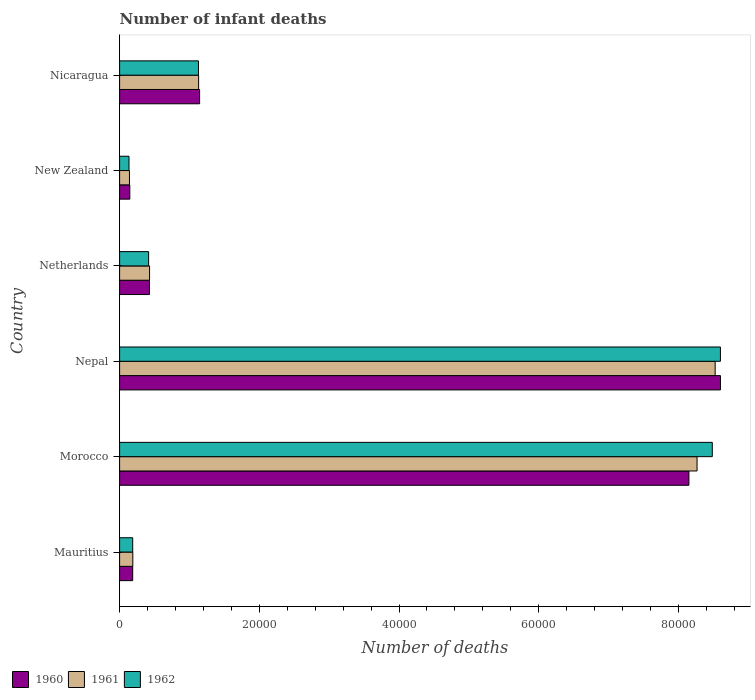Are the number of bars on each tick of the Y-axis equal?
Make the answer very short. Yes. What is the label of the 3rd group of bars from the top?
Make the answer very short. Netherlands. In how many cases, is the number of bars for a given country not equal to the number of legend labels?
Keep it short and to the point. 0. What is the number of infant deaths in 1960 in Netherlands?
Offer a very short reply. 4275. Across all countries, what is the maximum number of infant deaths in 1962?
Offer a terse response. 8.60e+04. Across all countries, what is the minimum number of infant deaths in 1962?
Your response must be concise. 1346. In which country was the number of infant deaths in 1962 maximum?
Keep it short and to the point. Nepal. In which country was the number of infant deaths in 1961 minimum?
Ensure brevity in your answer.  New Zealand. What is the total number of infant deaths in 1961 in the graph?
Provide a short and direct response. 1.87e+05. What is the difference between the number of infant deaths in 1960 in Morocco and that in Netherlands?
Offer a very short reply. 7.72e+04. What is the difference between the number of infant deaths in 1960 in New Zealand and the number of infant deaths in 1962 in Netherlands?
Provide a short and direct response. -2694. What is the average number of infant deaths in 1962 per country?
Offer a very short reply. 3.16e+04. What is the difference between the number of infant deaths in 1960 and number of infant deaths in 1962 in Netherlands?
Your answer should be compact. 120. What is the ratio of the number of infant deaths in 1960 in Mauritius to that in Nepal?
Give a very brief answer. 0.02. Is the difference between the number of infant deaths in 1960 in Netherlands and New Zealand greater than the difference between the number of infant deaths in 1962 in Netherlands and New Zealand?
Provide a succinct answer. Yes. What is the difference between the highest and the second highest number of infant deaths in 1962?
Make the answer very short. 1161. What is the difference between the highest and the lowest number of infant deaths in 1962?
Offer a very short reply. 8.47e+04. In how many countries, is the number of infant deaths in 1961 greater than the average number of infant deaths in 1961 taken over all countries?
Provide a succinct answer. 2. What does the 1st bar from the bottom in Nepal represents?
Provide a short and direct response. 1960. Is it the case that in every country, the sum of the number of infant deaths in 1961 and number of infant deaths in 1962 is greater than the number of infant deaths in 1960?
Make the answer very short. Yes. How many bars are there?
Give a very brief answer. 18. Are the values on the major ticks of X-axis written in scientific E-notation?
Provide a short and direct response. No. Where does the legend appear in the graph?
Offer a very short reply. Bottom left. What is the title of the graph?
Keep it short and to the point. Number of infant deaths. What is the label or title of the X-axis?
Provide a short and direct response. Number of deaths. What is the label or title of the Y-axis?
Offer a terse response. Country. What is the Number of deaths of 1960 in Mauritius?
Offer a very short reply. 1875. What is the Number of deaths of 1961 in Mauritius?
Offer a very short reply. 1890. What is the Number of deaths in 1962 in Mauritius?
Provide a succinct answer. 1876. What is the Number of deaths in 1960 in Morocco?
Your answer should be compact. 8.15e+04. What is the Number of deaths of 1961 in Morocco?
Provide a succinct answer. 8.27e+04. What is the Number of deaths in 1962 in Morocco?
Make the answer very short. 8.48e+04. What is the Number of deaths of 1960 in Nepal?
Provide a short and direct response. 8.60e+04. What is the Number of deaths in 1961 in Nepal?
Provide a succinct answer. 8.53e+04. What is the Number of deaths of 1962 in Nepal?
Provide a succinct answer. 8.60e+04. What is the Number of deaths of 1960 in Netherlands?
Your answer should be compact. 4275. What is the Number of deaths in 1961 in Netherlands?
Your answer should be very brief. 4288. What is the Number of deaths in 1962 in Netherlands?
Give a very brief answer. 4155. What is the Number of deaths in 1960 in New Zealand?
Provide a succinct answer. 1461. What is the Number of deaths in 1961 in New Zealand?
Offer a very short reply. 1412. What is the Number of deaths of 1962 in New Zealand?
Provide a short and direct response. 1346. What is the Number of deaths in 1960 in Nicaragua?
Your response must be concise. 1.15e+04. What is the Number of deaths in 1961 in Nicaragua?
Keep it short and to the point. 1.13e+04. What is the Number of deaths in 1962 in Nicaragua?
Ensure brevity in your answer.  1.13e+04. Across all countries, what is the maximum Number of deaths of 1960?
Keep it short and to the point. 8.60e+04. Across all countries, what is the maximum Number of deaths of 1961?
Your answer should be compact. 8.53e+04. Across all countries, what is the maximum Number of deaths in 1962?
Your response must be concise. 8.60e+04. Across all countries, what is the minimum Number of deaths in 1960?
Provide a short and direct response. 1461. Across all countries, what is the minimum Number of deaths in 1961?
Make the answer very short. 1412. Across all countries, what is the minimum Number of deaths of 1962?
Offer a very short reply. 1346. What is the total Number of deaths of 1960 in the graph?
Keep it short and to the point. 1.87e+05. What is the total Number of deaths in 1961 in the graph?
Offer a very short reply. 1.87e+05. What is the total Number of deaths of 1962 in the graph?
Provide a short and direct response. 1.90e+05. What is the difference between the Number of deaths in 1960 in Mauritius and that in Morocco?
Make the answer very short. -7.96e+04. What is the difference between the Number of deaths in 1961 in Mauritius and that in Morocco?
Offer a terse response. -8.08e+04. What is the difference between the Number of deaths of 1962 in Mauritius and that in Morocco?
Ensure brevity in your answer.  -8.30e+04. What is the difference between the Number of deaths in 1960 in Mauritius and that in Nepal?
Ensure brevity in your answer.  -8.41e+04. What is the difference between the Number of deaths in 1961 in Mauritius and that in Nepal?
Provide a succinct answer. -8.34e+04. What is the difference between the Number of deaths in 1962 in Mauritius and that in Nepal?
Provide a short and direct response. -8.41e+04. What is the difference between the Number of deaths of 1960 in Mauritius and that in Netherlands?
Keep it short and to the point. -2400. What is the difference between the Number of deaths in 1961 in Mauritius and that in Netherlands?
Provide a succinct answer. -2398. What is the difference between the Number of deaths of 1962 in Mauritius and that in Netherlands?
Provide a short and direct response. -2279. What is the difference between the Number of deaths of 1960 in Mauritius and that in New Zealand?
Keep it short and to the point. 414. What is the difference between the Number of deaths of 1961 in Mauritius and that in New Zealand?
Make the answer very short. 478. What is the difference between the Number of deaths in 1962 in Mauritius and that in New Zealand?
Make the answer very short. 530. What is the difference between the Number of deaths in 1960 in Mauritius and that in Nicaragua?
Your response must be concise. -9579. What is the difference between the Number of deaths of 1961 in Mauritius and that in Nicaragua?
Provide a succinct answer. -9420. What is the difference between the Number of deaths in 1962 in Mauritius and that in Nicaragua?
Provide a succinct answer. -9412. What is the difference between the Number of deaths of 1960 in Morocco and that in Nepal?
Make the answer very short. -4516. What is the difference between the Number of deaths in 1961 in Morocco and that in Nepal?
Make the answer very short. -2593. What is the difference between the Number of deaths in 1962 in Morocco and that in Nepal?
Keep it short and to the point. -1161. What is the difference between the Number of deaths of 1960 in Morocco and that in Netherlands?
Offer a very short reply. 7.72e+04. What is the difference between the Number of deaths in 1961 in Morocco and that in Netherlands?
Provide a short and direct response. 7.84e+04. What is the difference between the Number of deaths of 1962 in Morocco and that in Netherlands?
Provide a short and direct response. 8.07e+04. What is the difference between the Number of deaths in 1960 in Morocco and that in New Zealand?
Ensure brevity in your answer.  8.00e+04. What is the difference between the Number of deaths in 1961 in Morocco and that in New Zealand?
Offer a terse response. 8.12e+04. What is the difference between the Number of deaths in 1962 in Morocco and that in New Zealand?
Your answer should be compact. 8.35e+04. What is the difference between the Number of deaths in 1960 in Morocco and that in Nicaragua?
Provide a succinct answer. 7.00e+04. What is the difference between the Number of deaths in 1961 in Morocco and that in Nicaragua?
Make the answer very short. 7.14e+04. What is the difference between the Number of deaths of 1962 in Morocco and that in Nicaragua?
Keep it short and to the point. 7.36e+04. What is the difference between the Number of deaths in 1960 in Nepal and that in Netherlands?
Offer a very short reply. 8.17e+04. What is the difference between the Number of deaths of 1961 in Nepal and that in Netherlands?
Keep it short and to the point. 8.10e+04. What is the difference between the Number of deaths in 1962 in Nepal and that in Netherlands?
Provide a succinct answer. 8.19e+04. What is the difference between the Number of deaths of 1960 in Nepal and that in New Zealand?
Provide a short and direct response. 8.46e+04. What is the difference between the Number of deaths of 1961 in Nepal and that in New Zealand?
Offer a very short reply. 8.38e+04. What is the difference between the Number of deaths in 1962 in Nepal and that in New Zealand?
Your answer should be very brief. 8.47e+04. What is the difference between the Number of deaths in 1960 in Nepal and that in Nicaragua?
Offer a very short reply. 7.46e+04. What is the difference between the Number of deaths in 1961 in Nepal and that in Nicaragua?
Offer a terse response. 7.39e+04. What is the difference between the Number of deaths in 1962 in Nepal and that in Nicaragua?
Your response must be concise. 7.47e+04. What is the difference between the Number of deaths in 1960 in Netherlands and that in New Zealand?
Offer a terse response. 2814. What is the difference between the Number of deaths in 1961 in Netherlands and that in New Zealand?
Your response must be concise. 2876. What is the difference between the Number of deaths in 1962 in Netherlands and that in New Zealand?
Your response must be concise. 2809. What is the difference between the Number of deaths of 1960 in Netherlands and that in Nicaragua?
Your response must be concise. -7179. What is the difference between the Number of deaths in 1961 in Netherlands and that in Nicaragua?
Offer a terse response. -7022. What is the difference between the Number of deaths in 1962 in Netherlands and that in Nicaragua?
Your answer should be compact. -7133. What is the difference between the Number of deaths of 1960 in New Zealand and that in Nicaragua?
Offer a very short reply. -9993. What is the difference between the Number of deaths in 1961 in New Zealand and that in Nicaragua?
Your response must be concise. -9898. What is the difference between the Number of deaths of 1962 in New Zealand and that in Nicaragua?
Offer a very short reply. -9942. What is the difference between the Number of deaths of 1960 in Mauritius and the Number of deaths of 1961 in Morocco?
Give a very brief answer. -8.08e+04. What is the difference between the Number of deaths in 1960 in Mauritius and the Number of deaths in 1962 in Morocco?
Your answer should be compact. -8.30e+04. What is the difference between the Number of deaths of 1961 in Mauritius and the Number of deaths of 1962 in Morocco?
Your answer should be very brief. -8.30e+04. What is the difference between the Number of deaths in 1960 in Mauritius and the Number of deaths in 1961 in Nepal?
Offer a very short reply. -8.34e+04. What is the difference between the Number of deaths of 1960 in Mauritius and the Number of deaths of 1962 in Nepal?
Provide a short and direct response. -8.41e+04. What is the difference between the Number of deaths of 1961 in Mauritius and the Number of deaths of 1962 in Nepal?
Give a very brief answer. -8.41e+04. What is the difference between the Number of deaths in 1960 in Mauritius and the Number of deaths in 1961 in Netherlands?
Make the answer very short. -2413. What is the difference between the Number of deaths in 1960 in Mauritius and the Number of deaths in 1962 in Netherlands?
Your answer should be compact. -2280. What is the difference between the Number of deaths in 1961 in Mauritius and the Number of deaths in 1962 in Netherlands?
Offer a very short reply. -2265. What is the difference between the Number of deaths in 1960 in Mauritius and the Number of deaths in 1961 in New Zealand?
Give a very brief answer. 463. What is the difference between the Number of deaths in 1960 in Mauritius and the Number of deaths in 1962 in New Zealand?
Ensure brevity in your answer.  529. What is the difference between the Number of deaths in 1961 in Mauritius and the Number of deaths in 1962 in New Zealand?
Offer a terse response. 544. What is the difference between the Number of deaths of 1960 in Mauritius and the Number of deaths of 1961 in Nicaragua?
Your answer should be very brief. -9435. What is the difference between the Number of deaths of 1960 in Mauritius and the Number of deaths of 1962 in Nicaragua?
Your answer should be very brief. -9413. What is the difference between the Number of deaths of 1961 in Mauritius and the Number of deaths of 1962 in Nicaragua?
Your answer should be very brief. -9398. What is the difference between the Number of deaths in 1960 in Morocco and the Number of deaths in 1961 in Nepal?
Your answer should be compact. -3759. What is the difference between the Number of deaths of 1960 in Morocco and the Number of deaths of 1962 in Nepal?
Keep it short and to the point. -4511. What is the difference between the Number of deaths in 1961 in Morocco and the Number of deaths in 1962 in Nepal?
Your answer should be compact. -3345. What is the difference between the Number of deaths in 1960 in Morocco and the Number of deaths in 1961 in Netherlands?
Provide a succinct answer. 7.72e+04. What is the difference between the Number of deaths of 1960 in Morocco and the Number of deaths of 1962 in Netherlands?
Your answer should be very brief. 7.73e+04. What is the difference between the Number of deaths of 1961 in Morocco and the Number of deaths of 1962 in Netherlands?
Your answer should be very brief. 7.85e+04. What is the difference between the Number of deaths in 1960 in Morocco and the Number of deaths in 1961 in New Zealand?
Your answer should be very brief. 8.01e+04. What is the difference between the Number of deaths in 1960 in Morocco and the Number of deaths in 1962 in New Zealand?
Your answer should be very brief. 8.01e+04. What is the difference between the Number of deaths of 1961 in Morocco and the Number of deaths of 1962 in New Zealand?
Keep it short and to the point. 8.13e+04. What is the difference between the Number of deaths in 1960 in Morocco and the Number of deaths in 1961 in Nicaragua?
Provide a succinct answer. 7.02e+04. What is the difference between the Number of deaths in 1960 in Morocco and the Number of deaths in 1962 in Nicaragua?
Give a very brief answer. 7.02e+04. What is the difference between the Number of deaths of 1961 in Morocco and the Number of deaths of 1962 in Nicaragua?
Make the answer very short. 7.14e+04. What is the difference between the Number of deaths in 1960 in Nepal and the Number of deaths in 1961 in Netherlands?
Your response must be concise. 8.17e+04. What is the difference between the Number of deaths of 1960 in Nepal and the Number of deaths of 1962 in Netherlands?
Provide a short and direct response. 8.19e+04. What is the difference between the Number of deaths in 1961 in Nepal and the Number of deaths in 1962 in Netherlands?
Your answer should be very brief. 8.11e+04. What is the difference between the Number of deaths of 1960 in Nepal and the Number of deaths of 1961 in New Zealand?
Your answer should be very brief. 8.46e+04. What is the difference between the Number of deaths in 1960 in Nepal and the Number of deaths in 1962 in New Zealand?
Ensure brevity in your answer.  8.47e+04. What is the difference between the Number of deaths in 1961 in Nepal and the Number of deaths in 1962 in New Zealand?
Give a very brief answer. 8.39e+04. What is the difference between the Number of deaths of 1960 in Nepal and the Number of deaths of 1961 in Nicaragua?
Offer a very short reply. 7.47e+04. What is the difference between the Number of deaths of 1960 in Nepal and the Number of deaths of 1962 in Nicaragua?
Offer a terse response. 7.47e+04. What is the difference between the Number of deaths of 1961 in Nepal and the Number of deaths of 1962 in Nicaragua?
Offer a terse response. 7.40e+04. What is the difference between the Number of deaths in 1960 in Netherlands and the Number of deaths in 1961 in New Zealand?
Offer a very short reply. 2863. What is the difference between the Number of deaths of 1960 in Netherlands and the Number of deaths of 1962 in New Zealand?
Your response must be concise. 2929. What is the difference between the Number of deaths in 1961 in Netherlands and the Number of deaths in 1962 in New Zealand?
Give a very brief answer. 2942. What is the difference between the Number of deaths in 1960 in Netherlands and the Number of deaths in 1961 in Nicaragua?
Offer a very short reply. -7035. What is the difference between the Number of deaths of 1960 in Netherlands and the Number of deaths of 1962 in Nicaragua?
Your response must be concise. -7013. What is the difference between the Number of deaths in 1961 in Netherlands and the Number of deaths in 1962 in Nicaragua?
Keep it short and to the point. -7000. What is the difference between the Number of deaths in 1960 in New Zealand and the Number of deaths in 1961 in Nicaragua?
Keep it short and to the point. -9849. What is the difference between the Number of deaths in 1960 in New Zealand and the Number of deaths in 1962 in Nicaragua?
Make the answer very short. -9827. What is the difference between the Number of deaths in 1961 in New Zealand and the Number of deaths in 1962 in Nicaragua?
Give a very brief answer. -9876. What is the average Number of deaths of 1960 per country?
Ensure brevity in your answer.  3.11e+04. What is the average Number of deaths in 1961 per country?
Your answer should be compact. 3.11e+04. What is the average Number of deaths in 1962 per country?
Offer a terse response. 3.16e+04. What is the difference between the Number of deaths of 1960 and Number of deaths of 1961 in Morocco?
Keep it short and to the point. -1166. What is the difference between the Number of deaths of 1960 and Number of deaths of 1962 in Morocco?
Give a very brief answer. -3350. What is the difference between the Number of deaths of 1961 and Number of deaths of 1962 in Morocco?
Make the answer very short. -2184. What is the difference between the Number of deaths of 1960 and Number of deaths of 1961 in Nepal?
Your answer should be very brief. 757. What is the difference between the Number of deaths of 1960 and Number of deaths of 1962 in Nepal?
Your response must be concise. 5. What is the difference between the Number of deaths of 1961 and Number of deaths of 1962 in Nepal?
Your answer should be compact. -752. What is the difference between the Number of deaths in 1960 and Number of deaths in 1961 in Netherlands?
Your answer should be very brief. -13. What is the difference between the Number of deaths in 1960 and Number of deaths in 1962 in Netherlands?
Your answer should be very brief. 120. What is the difference between the Number of deaths in 1961 and Number of deaths in 1962 in Netherlands?
Ensure brevity in your answer.  133. What is the difference between the Number of deaths of 1960 and Number of deaths of 1962 in New Zealand?
Give a very brief answer. 115. What is the difference between the Number of deaths in 1960 and Number of deaths in 1961 in Nicaragua?
Make the answer very short. 144. What is the difference between the Number of deaths in 1960 and Number of deaths in 1962 in Nicaragua?
Your response must be concise. 166. What is the ratio of the Number of deaths in 1960 in Mauritius to that in Morocco?
Your answer should be compact. 0.02. What is the ratio of the Number of deaths in 1961 in Mauritius to that in Morocco?
Your answer should be very brief. 0.02. What is the ratio of the Number of deaths in 1962 in Mauritius to that in Morocco?
Make the answer very short. 0.02. What is the ratio of the Number of deaths of 1960 in Mauritius to that in Nepal?
Your response must be concise. 0.02. What is the ratio of the Number of deaths in 1961 in Mauritius to that in Nepal?
Provide a short and direct response. 0.02. What is the ratio of the Number of deaths in 1962 in Mauritius to that in Nepal?
Your answer should be compact. 0.02. What is the ratio of the Number of deaths of 1960 in Mauritius to that in Netherlands?
Offer a very short reply. 0.44. What is the ratio of the Number of deaths in 1961 in Mauritius to that in Netherlands?
Your answer should be compact. 0.44. What is the ratio of the Number of deaths in 1962 in Mauritius to that in Netherlands?
Your response must be concise. 0.45. What is the ratio of the Number of deaths of 1960 in Mauritius to that in New Zealand?
Make the answer very short. 1.28. What is the ratio of the Number of deaths in 1961 in Mauritius to that in New Zealand?
Provide a succinct answer. 1.34. What is the ratio of the Number of deaths of 1962 in Mauritius to that in New Zealand?
Your response must be concise. 1.39. What is the ratio of the Number of deaths of 1960 in Mauritius to that in Nicaragua?
Provide a short and direct response. 0.16. What is the ratio of the Number of deaths in 1961 in Mauritius to that in Nicaragua?
Give a very brief answer. 0.17. What is the ratio of the Number of deaths in 1962 in Mauritius to that in Nicaragua?
Your answer should be compact. 0.17. What is the ratio of the Number of deaths in 1960 in Morocco to that in Nepal?
Your answer should be compact. 0.95. What is the ratio of the Number of deaths of 1961 in Morocco to that in Nepal?
Give a very brief answer. 0.97. What is the ratio of the Number of deaths in 1962 in Morocco to that in Nepal?
Make the answer very short. 0.99. What is the ratio of the Number of deaths in 1960 in Morocco to that in Netherlands?
Offer a very short reply. 19.06. What is the ratio of the Number of deaths in 1961 in Morocco to that in Netherlands?
Your response must be concise. 19.28. What is the ratio of the Number of deaths in 1962 in Morocco to that in Netherlands?
Offer a terse response. 20.42. What is the ratio of the Number of deaths in 1960 in Morocco to that in New Zealand?
Your response must be concise. 55.78. What is the ratio of the Number of deaths in 1961 in Morocco to that in New Zealand?
Keep it short and to the point. 58.54. What is the ratio of the Number of deaths in 1962 in Morocco to that in New Zealand?
Provide a short and direct response. 63.03. What is the ratio of the Number of deaths in 1960 in Morocco to that in Nicaragua?
Provide a succinct answer. 7.12. What is the ratio of the Number of deaths in 1961 in Morocco to that in Nicaragua?
Offer a very short reply. 7.31. What is the ratio of the Number of deaths of 1962 in Morocco to that in Nicaragua?
Your answer should be very brief. 7.52. What is the ratio of the Number of deaths in 1960 in Nepal to that in Netherlands?
Your answer should be very brief. 20.12. What is the ratio of the Number of deaths in 1961 in Nepal to that in Netherlands?
Ensure brevity in your answer.  19.88. What is the ratio of the Number of deaths of 1962 in Nepal to that in Netherlands?
Make the answer very short. 20.7. What is the ratio of the Number of deaths in 1960 in Nepal to that in New Zealand?
Provide a short and direct response. 58.87. What is the ratio of the Number of deaths in 1961 in Nepal to that in New Zealand?
Ensure brevity in your answer.  60.38. What is the ratio of the Number of deaths of 1962 in Nepal to that in New Zealand?
Offer a very short reply. 63.9. What is the ratio of the Number of deaths in 1960 in Nepal to that in Nicaragua?
Offer a terse response. 7.51. What is the ratio of the Number of deaths of 1961 in Nepal to that in Nicaragua?
Your response must be concise. 7.54. What is the ratio of the Number of deaths in 1962 in Nepal to that in Nicaragua?
Provide a succinct answer. 7.62. What is the ratio of the Number of deaths of 1960 in Netherlands to that in New Zealand?
Your response must be concise. 2.93. What is the ratio of the Number of deaths of 1961 in Netherlands to that in New Zealand?
Your response must be concise. 3.04. What is the ratio of the Number of deaths of 1962 in Netherlands to that in New Zealand?
Your answer should be very brief. 3.09. What is the ratio of the Number of deaths in 1960 in Netherlands to that in Nicaragua?
Keep it short and to the point. 0.37. What is the ratio of the Number of deaths in 1961 in Netherlands to that in Nicaragua?
Your response must be concise. 0.38. What is the ratio of the Number of deaths in 1962 in Netherlands to that in Nicaragua?
Ensure brevity in your answer.  0.37. What is the ratio of the Number of deaths in 1960 in New Zealand to that in Nicaragua?
Provide a short and direct response. 0.13. What is the ratio of the Number of deaths of 1961 in New Zealand to that in Nicaragua?
Your answer should be compact. 0.12. What is the ratio of the Number of deaths in 1962 in New Zealand to that in Nicaragua?
Your answer should be compact. 0.12. What is the difference between the highest and the second highest Number of deaths of 1960?
Give a very brief answer. 4516. What is the difference between the highest and the second highest Number of deaths of 1961?
Provide a short and direct response. 2593. What is the difference between the highest and the second highest Number of deaths of 1962?
Offer a terse response. 1161. What is the difference between the highest and the lowest Number of deaths in 1960?
Provide a succinct answer. 8.46e+04. What is the difference between the highest and the lowest Number of deaths in 1961?
Offer a very short reply. 8.38e+04. What is the difference between the highest and the lowest Number of deaths in 1962?
Keep it short and to the point. 8.47e+04. 